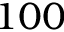<formula> <loc_0><loc_0><loc_500><loc_500>1 0 0</formula> 